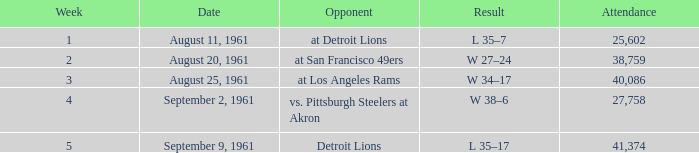What was the outcome of the browns' week 4 game? W 38–6. 